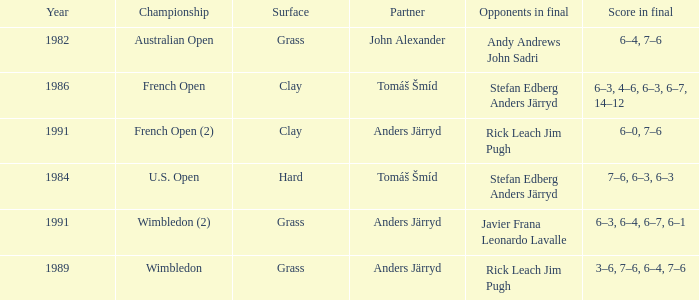Can you give me this table as a dict? {'header': ['Year', 'Championship', 'Surface', 'Partner', 'Opponents in final', 'Score in final'], 'rows': [['1982', 'Australian Open', 'Grass', 'John Alexander', 'Andy Andrews John Sadri', '6–4, 7–6'], ['1986', 'French Open', 'Clay', 'Tomáš Šmíd', 'Stefan Edberg Anders Järryd', '6–3, 4–6, 6–3, 6–7, 14–12'], ['1991', 'French Open (2)', 'Clay', 'Anders Järryd', 'Rick Leach Jim Pugh', '6–0, 7–6'], ['1984', 'U.S. Open', 'Hard', 'Tomáš Šmíd', 'Stefan Edberg Anders Järryd', '7–6, 6–3, 6–3'], ['1991', 'Wimbledon (2)', 'Grass', 'Anders Järryd', 'Javier Frana Leonardo Lavalle', '6–3, 6–4, 6–7, 6–1'], ['1989', 'Wimbledon', 'Grass', 'Anders Järryd', 'Rick Leach Jim Pugh', '3–6, 7–6, 6–4, 7–6']]} What was the surface when he played with John Alexander?  Grass. 